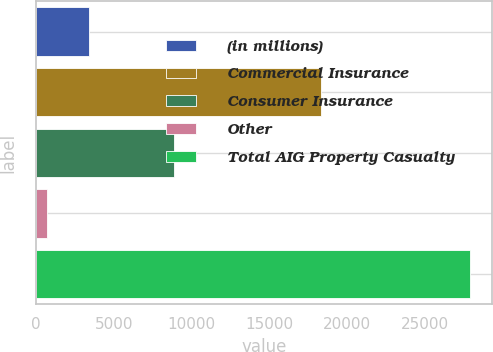Convert chart to OTSL. <chart><loc_0><loc_0><loc_500><loc_500><bar_chart><fcel>(in millions)<fcel>Commercial Insurance<fcel>Consumer Insurance<fcel>Other<fcel>Total AIG Property Casualty<nl><fcel>3440.2<fcel>18332<fcel>8900<fcel>717<fcel>27949<nl></chart> 